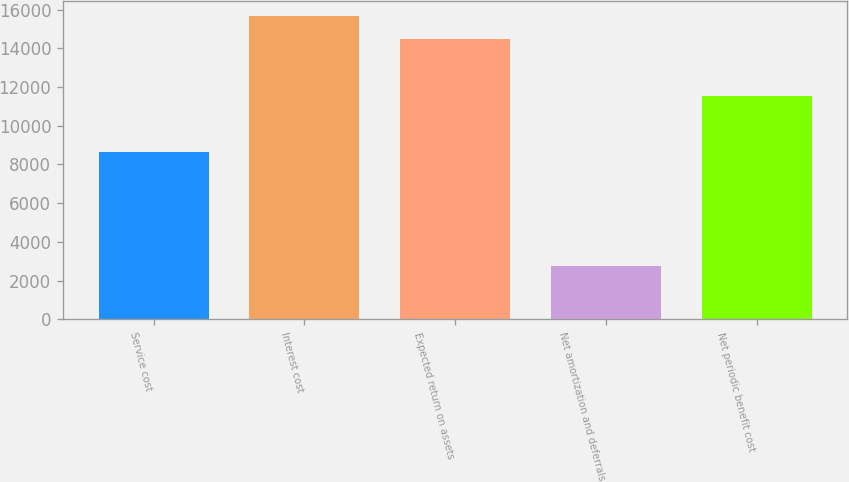<chart> <loc_0><loc_0><loc_500><loc_500><bar_chart><fcel>Service cost<fcel>Interest cost<fcel>Expected return on assets<fcel>Net amortization and deferrals<fcel>Net periodic benefit cost<nl><fcel>8632<fcel>15677<fcel>14489<fcel>2750<fcel>11523<nl></chart> 